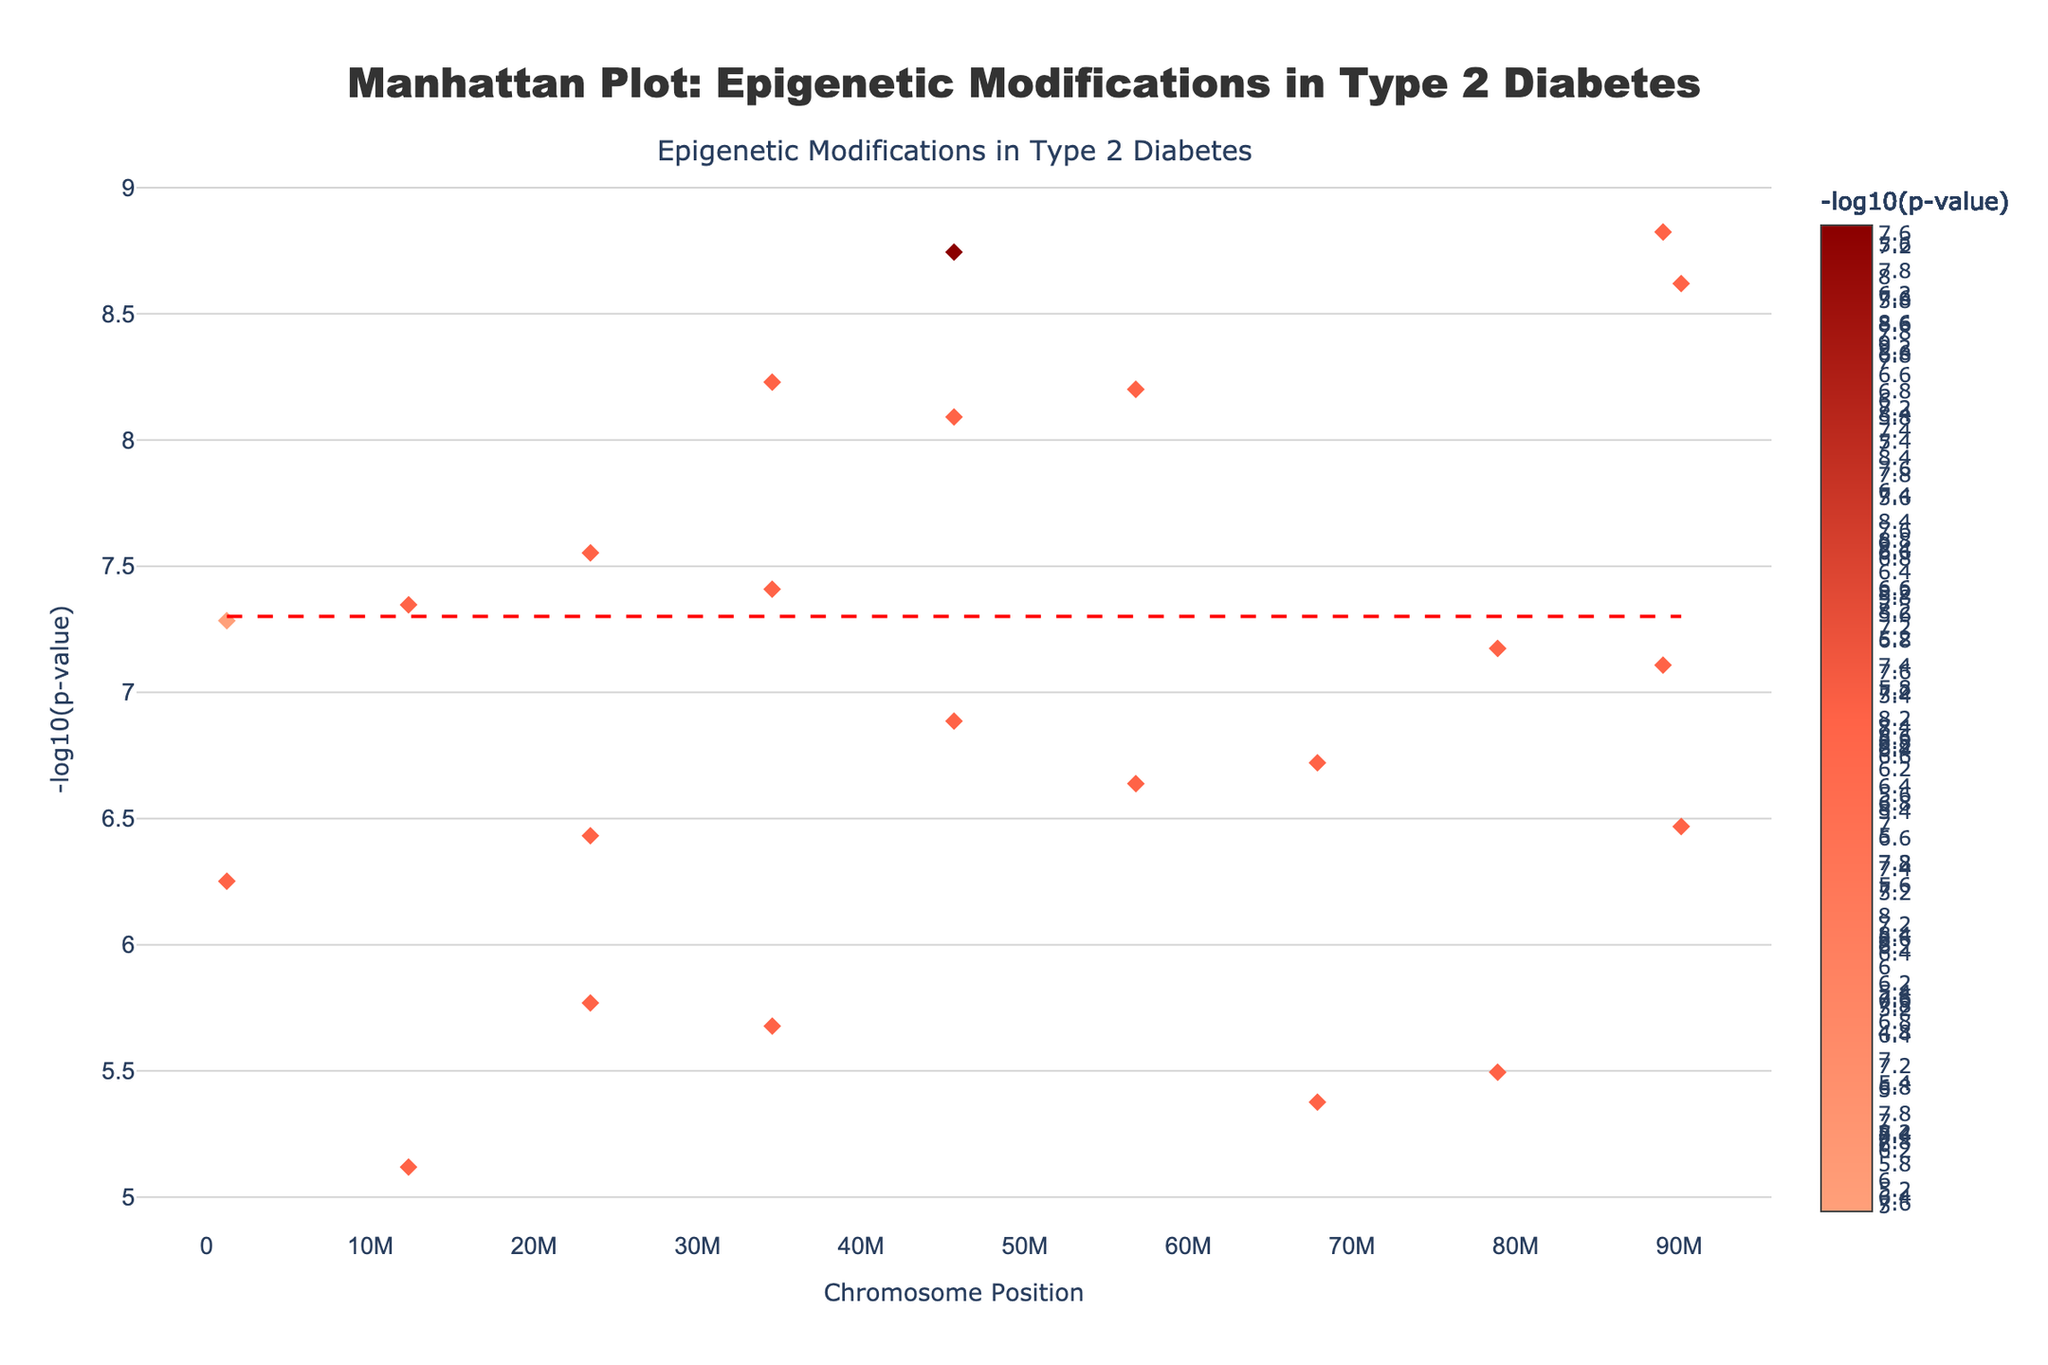What is the title of the plot? The title is displayed at the center top of the figure. It is written in a large and bold font.
Answer: Manhattan Plot: Epigenetic Modifications in Type 2 Diabetes What is the y-axis representing on this plot? The y-axis label indicates "-log10(p-value)," which represents the negative logarithm (base 10) of the p-values of the genetic associations. This helps in visualizing very small p-values effectively.
Answer: -log10(p-value) Which chromosome has the data point with the smallest p-value? The smallest p-value corresponds to the highest point on the y-axis. Hover information confirms that Chromosome 1 with TCF7L2 and p-value 1.8e-9 is the smallest.
Answer: Chromosome 1 Which DNA modification type is associated with the gene HNF1B? By hovering over the data points, we can see the modification type for each gene. For HNF1B, it shows "Modification: Methylation."
Answer: Methylation What is the significance threshold indicated by the red dashed line, and why is it important? The red dashed line indicates a p-value threshold of 5e-8 (as shown by its position on the y-axis). It differentiates significant associations (above the line) from non-significant ones (below).
Answer: 5e-8 How many genes have their modification type as Acetylation? By analyzing the hover information or counting markers manually, we see that genes TCF7L2, SLC30A8, CDKAL1, CDKN2A, etc., are acetylated, totaling 11.
Answer: 11 Which chromosome displayed data points have the highest and lowest log10(p-value)? The highest point can be located on Chromosome 1 (TCF7L2) with -log10(1.8e-9) ≈ 8.74. The lowest can be found on Chromosome 19 (GIPR) with -log10(7.6e-6) ≈ 5.12.
Answer: Chromosome 1 and Chromosome 19 Compare the -log10(p-value) values of genes IRS1 and CDKAL1; which one is higher? IRS1 (-log10(3.7e-7) ≈ 6.43) and CDKAL1 (-log10(1.9e-7) ≈ 6.72). Comparing these values, CDKAL1 is higher.
Answer: CDKAL1 How is the color of the points related to the -log10(p-value)? The color intensity correlates with the -log10(p-value). Darker colors indicate higher -log10(p-values), which means stronger associations.
Answer: Intensity of color 